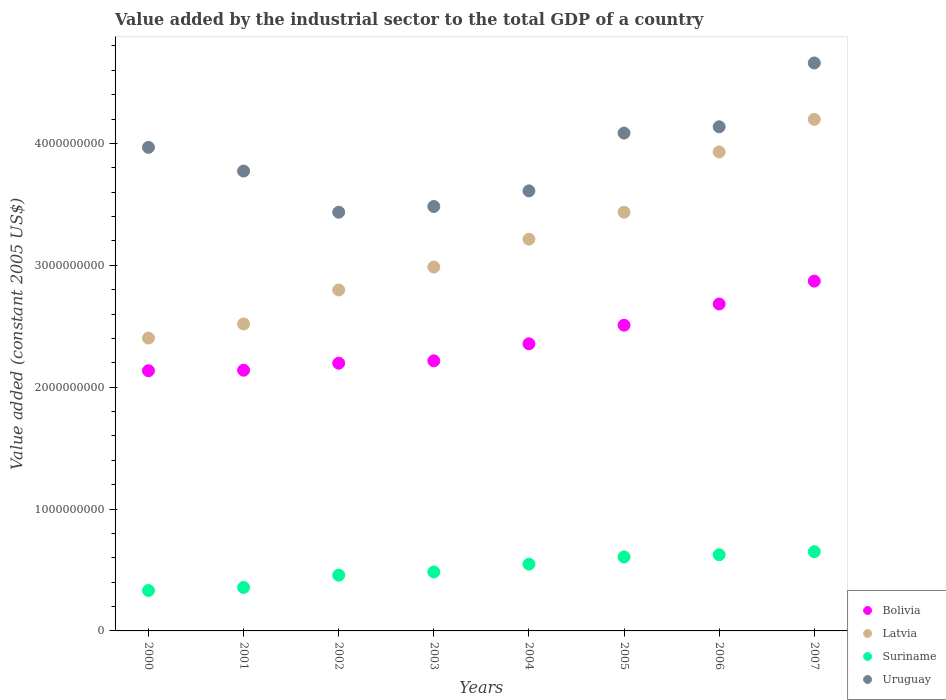How many different coloured dotlines are there?
Make the answer very short. 4. Is the number of dotlines equal to the number of legend labels?
Your answer should be compact. Yes. What is the value added by the industrial sector in Latvia in 2004?
Your answer should be compact. 3.21e+09. Across all years, what is the maximum value added by the industrial sector in Suriname?
Keep it short and to the point. 6.50e+08. Across all years, what is the minimum value added by the industrial sector in Latvia?
Provide a succinct answer. 2.40e+09. In which year was the value added by the industrial sector in Latvia maximum?
Provide a succinct answer. 2007. In which year was the value added by the industrial sector in Suriname minimum?
Make the answer very short. 2000. What is the total value added by the industrial sector in Latvia in the graph?
Ensure brevity in your answer.  2.55e+1. What is the difference between the value added by the industrial sector in Uruguay in 2003 and that in 2004?
Offer a very short reply. -1.28e+08. What is the difference between the value added by the industrial sector in Latvia in 2000 and the value added by the industrial sector in Uruguay in 2005?
Give a very brief answer. -1.68e+09. What is the average value added by the industrial sector in Latvia per year?
Your response must be concise. 3.19e+09. In the year 2006, what is the difference between the value added by the industrial sector in Bolivia and value added by the industrial sector in Suriname?
Keep it short and to the point. 2.06e+09. In how many years, is the value added by the industrial sector in Bolivia greater than 200000000 US$?
Your answer should be compact. 8. What is the ratio of the value added by the industrial sector in Suriname in 2003 to that in 2006?
Make the answer very short. 0.77. Is the value added by the industrial sector in Latvia in 2006 less than that in 2007?
Your answer should be very brief. Yes. What is the difference between the highest and the second highest value added by the industrial sector in Uruguay?
Offer a terse response. 5.24e+08. What is the difference between the highest and the lowest value added by the industrial sector in Latvia?
Your answer should be compact. 1.79e+09. In how many years, is the value added by the industrial sector in Latvia greater than the average value added by the industrial sector in Latvia taken over all years?
Your answer should be very brief. 4. Is it the case that in every year, the sum of the value added by the industrial sector in Latvia and value added by the industrial sector in Uruguay  is greater than the sum of value added by the industrial sector in Bolivia and value added by the industrial sector in Suriname?
Offer a terse response. Yes. Does the value added by the industrial sector in Latvia monotonically increase over the years?
Keep it short and to the point. Yes. How many years are there in the graph?
Make the answer very short. 8. Does the graph contain grids?
Make the answer very short. No. Where does the legend appear in the graph?
Keep it short and to the point. Bottom right. How many legend labels are there?
Offer a very short reply. 4. How are the legend labels stacked?
Provide a short and direct response. Vertical. What is the title of the graph?
Provide a succinct answer. Value added by the industrial sector to the total GDP of a country. What is the label or title of the X-axis?
Keep it short and to the point. Years. What is the label or title of the Y-axis?
Your answer should be compact. Value added (constant 2005 US$). What is the Value added (constant 2005 US$) of Bolivia in 2000?
Your answer should be very brief. 2.13e+09. What is the Value added (constant 2005 US$) in Latvia in 2000?
Offer a very short reply. 2.40e+09. What is the Value added (constant 2005 US$) of Suriname in 2000?
Your answer should be compact. 3.31e+08. What is the Value added (constant 2005 US$) of Uruguay in 2000?
Offer a very short reply. 3.97e+09. What is the Value added (constant 2005 US$) of Bolivia in 2001?
Make the answer very short. 2.14e+09. What is the Value added (constant 2005 US$) in Latvia in 2001?
Your answer should be compact. 2.52e+09. What is the Value added (constant 2005 US$) in Suriname in 2001?
Make the answer very short. 3.57e+08. What is the Value added (constant 2005 US$) in Uruguay in 2001?
Make the answer very short. 3.77e+09. What is the Value added (constant 2005 US$) of Bolivia in 2002?
Make the answer very short. 2.20e+09. What is the Value added (constant 2005 US$) of Latvia in 2002?
Your answer should be very brief. 2.80e+09. What is the Value added (constant 2005 US$) of Suriname in 2002?
Keep it short and to the point. 4.58e+08. What is the Value added (constant 2005 US$) of Uruguay in 2002?
Keep it short and to the point. 3.44e+09. What is the Value added (constant 2005 US$) of Bolivia in 2003?
Provide a succinct answer. 2.22e+09. What is the Value added (constant 2005 US$) of Latvia in 2003?
Keep it short and to the point. 2.99e+09. What is the Value added (constant 2005 US$) of Suriname in 2003?
Ensure brevity in your answer.  4.84e+08. What is the Value added (constant 2005 US$) of Uruguay in 2003?
Your response must be concise. 3.48e+09. What is the Value added (constant 2005 US$) in Bolivia in 2004?
Give a very brief answer. 2.36e+09. What is the Value added (constant 2005 US$) in Latvia in 2004?
Offer a terse response. 3.21e+09. What is the Value added (constant 2005 US$) of Suriname in 2004?
Your response must be concise. 5.48e+08. What is the Value added (constant 2005 US$) in Uruguay in 2004?
Your answer should be compact. 3.61e+09. What is the Value added (constant 2005 US$) of Bolivia in 2005?
Your answer should be very brief. 2.51e+09. What is the Value added (constant 2005 US$) of Latvia in 2005?
Offer a terse response. 3.44e+09. What is the Value added (constant 2005 US$) in Suriname in 2005?
Provide a succinct answer. 6.07e+08. What is the Value added (constant 2005 US$) in Uruguay in 2005?
Ensure brevity in your answer.  4.08e+09. What is the Value added (constant 2005 US$) in Bolivia in 2006?
Keep it short and to the point. 2.68e+09. What is the Value added (constant 2005 US$) of Latvia in 2006?
Provide a succinct answer. 3.93e+09. What is the Value added (constant 2005 US$) of Suriname in 2006?
Offer a terse response. 6.25e+08. What is the Value added (constant 2005 US$) in Uruguay in 2006?
Keep it short and to the point. 4.14e+09. What is the Value added (constant 2005 US$) of Bolivia in 2007?
Provide a short and direct response. 2.87e+09. What is the Value added (constant 2005 US$) of Latvia in 2007?
Provide a short and direct response. 4.20e+09. What is the Value added (constant 2005 US$) in Suriname in 2007?
Your response must be concise. 6.50e+08. What is the Value added (constant 2005 US$) of Uruguay in 2007?
Your response must be concise. 4.66e+09. Across all years, what is the maximum Value added (constant 2005 US$) in Bolivia?
Give a very brief answer. 2.87e+09. Across all years, what is the maximum Value added (constant 2005 US$) in Latvia?
Make the answer very short. 4.20e+09. Across all years, what is the maximum Value added (constant 2005 US$) of Suriname?
Your answer should be compact. 6.50e+08. Across all years, what is the maximum Value added (constant 2005 US$) in Uruguay?
Keep it short and to the point. 4.66e+09. Across all years, what is the minimum Value added (constant 2005 US$) of Bolivia?
Your response must be concise. 2.13e+09. Across all years, what is the minimum Value added (constant 2005 US$) of Latvia?
Ensure brevity in your answer.  2.40e+09. Across all years, what is the minimum Value added (constant 2005 US$) in Suriname?
Give a very brief answer. 3.31e+08. Across all years, what is the minimum Value added (constant 2005 US$) of Uruguay?
Provide a short and direct response. 3.44e+09. What is the total Value added (constant 2005 US$) in Bolivia in the graph?
Provide a succinct answer. 1.91e+1. What is the total Value added (constant 2005 US$) of Latvia in the graph?
Make the answer very short. 2.55e+1. What is the total Value added (constant 2005 US$) in Suriname in the graph?
Make the answer very short. 4.06e+09. What is the total Value added (constant 2005 US$) in Uruguay in the graph?
Give a very brief answer. 3.12e+1. What is the difference between the Value added (constant 2005 US$) of Bolivia in 2000 and that in 2001?
Give a very brief answer. -4.43e+06. What is the difference between the Value added (constant 2005 US$) in Latvia in 2000 and that in 2001?
Give a very brief answer. -1.16e+08. What is the difference between the Value added (constant 2005 US$) of Suriname in 2000 and that in 2001?
Offer a very short reply. -2.52e+07. What is the difference between the Value added (constant 2005 US$) in Uruguay in 2000 and that in 2001?
Your answer should be very brief. 1.94e+08. What is the difference between the Value added (constant 2005 US$) in Bolivia in 2000 and that in 2002?
Keep it short and to the point. -6.17e+07. What is the difference between the Value added (constant 2005 US$) in Latvia in 2000 and that in 2002?
Your answer should be compact. -3.95e+08. What is the difference between the Value added (constant 2005 US$) of Suriname in 2000 and that in 2002?
Give a very brief answer. -1.26e+08. What is the difference between the Value added (constant 2005 US$) in Uruguay in 2000 and that in 2002?
Provide a succinct answer. 5.32e+08. What is the difference between the Value added (constant 2005 US$) of Bolivia in 2000 and that in 2003?
Offer a very short reply. -8.14e+07. What is the difference between the Value added (constant 2005 US$) in Latvia in 2000 and that in 2003?
Make the answer very short. -5.83e+08. What is the difference between the Value added (constant 2005 US$) in Suriname in 2000 and that in 2003?
Ensure brevity in your answer.  -1.52e+08. What is the difference between the Value added (constant 2005 US$) of Uruguay in 2000 and that in 2003?
Offer a very short reply. 4.85e+08. What is the difference between the Value added (constant 2005 US$) in Bolivia in 2000 and that in 2004?
Your response must be concise. -2.21e+08. What is the difference between the Value added (constant 2005 US$) of Latvia in 2000 and that in 2004?
Your response must be concise. -8.11e+08. What is the difference between the Value added (constant 2005 US$) in Suriname in 2000 and that in 2004?
Offer a terse response. -2.16e+08. What is the difference between the Value added (constant 2005 US$) of Uruguay in 2000 and that in 2004?
Offer a terse response. 3.57e+08. What is the difference between the Value added (constant 2005 US$) in Bolivia in 2000 and that in 2005?
Provide a succinct answer. -3.74e+08. What is the difference between the Value added (constant 2005 US$) in Latvia in 2000 and that in 2005?
Your answer should be compact. -1.03e+09. What is the difference between the Value added (constant 2005 US$) in Suriname in 2000 and that in 2005?
Provide a short and direct response. -2.75e+08. What is the difference between the Value added (constant 2005 US$) of Uruguay in 2000 and that in 2005?
Your response must be concise. -1.17e+08. What is the difference between the Value added (constant 2005 US$) in Bolivia in 2000 and that in 2006?
Your response must be concise. -5.48e+08. What is the difference between the Value added (constant 2005 US$) of Latvia in 2000 and that in 2006?
Make the answer very short. -1.53e+09. What is the difference between the Value added (constant 2005 US$) in Suriname in 2000 and that in 2006?
Provide a short and direct response. -2.94e+08. What is the difference between the Value added (constant 2005 US$) of Uruguay in 2000 and that in 2006?
Your answer should be compact. -1.69e+08. What is the difference between the Value added (constant 2005 US$) in Bolivia in 2000 and that in 2007?
Give a very brief answer. -7.35e+08. What is the difference between the Value added (constant 2005 US$) in Latvia in 2000 and that in 2007?
Your answer should be compact. -1.79e+09. What is the difference between the Value added (constant 2005 US$) in Suriname in 2000 and that in 2007?
Make the answer very short. -3.18e+08. What is the difference between the Value added (constant 2005 US$) of Uruguay in 2000 and that in 2007?
Make the answer very short. -6.93e+08. What is the difference between the Value added (constant 2005 US$) of Bolivia in 2001 and that in 2002?
Offer a very short reply. -5.73e+07. What is the difference between the Value added (constant 2005 US$) of Latvia in 2001 and that in 2002?
Provide a short and direct response. -2.79e+08. What is the difference between the Value added (constant 2005 US$) of Suriname in 2001 and that in 2002?
Offer a very short reply. -1.01e+08. What is the difference between the Value added (constant 2005 US$) in Uruguay in 2001 and that in 2002?
Your answer should be very brief. 3.38e+08. What is the difference between the Value added (constant 2005 US$) in Bolivia in 2001 and that in 2003?
Offer a very short reply. -7.70e+07. What is the difference between the Value added (constant 2005 US$) of Latvia in 2001 and that in 2003?
Your response must be concise. -4.67e+08. What is the difference between the Value added (constant 2005 US$) in Suriname in 2001 and that in 2003?
Give a very brief answer. -1.27e+08. What is the difference between the Value added (constant 2005 US$) in Uruguay in 2001 and that in 2003?
Make the answer very short. 2.91e+08. What is the difference between the Value added (constant 2005 US$) of Bolivia in 2001 and that in 2004?
Ensure brevity in your answer.  -2.17e+08. What is the difference between the Value added (constant 2005 US$) of Latvia in 2001 and that in 2004?
Give a very brief answer. -6.95e+08. What is the difference between the Value added (constant 2005 US$) in Suriname in 2001 and that in 2004?
Make the answer very short. -1.91e+08. What is the difference between the Value added (constant 2005 US$) of Uruguay in 2001 and that in 2004?
Offer a terse response. 1.63e+08. What is the difference between the Value added (constant 2005 US$) of Bolivia in 2001 and that in 2005?
Provide a short and direct response. -3.69e+08. What is the difference between the Value added (constant 2005 US$) of Latvia in 2001 and that in 2005?
Give a very brief answer. -9.17e+08. What is the difference between the Value added (constant 2005 US$) of Suriname in 2001 and that in 2005?
Make the answer very short. -2.50e+08. What is the difference between the Value added (constant 2005 US$) of Uruguay in 2001 and that in 2005?
Offer a very short reply. -3.11e+08. What is the difference between the Value added (constant 2005 US$) in Bolivia in 2001 and that in 2006?
Provide a short and direct response. -5.43e+08. What is the difference between the Value added (constant 2005 US$) of Latvia in 2001 and that in 2006?
Provide a succinct answer. -1.41e+09. What is the difference between the Value added (constant 2005 US$) in Suriname in 2001 and that in 2006?
Your response must be concise. -2.68e+08. What is the difference between the Value added (constant 2005 US$) of Uruguay in 2001 and that in 2006?
Offer a very short reply. -3.63e+08. What is the difference between the Value added (constant 2005 US$) in Bolivia in 2001 and that in 2007?
Offer a terse response. -7.31e+08. What is the difference between the Value added (constant 2005 US$) of Latvia in 2001 and that in 2007?
Offer a terse response. -1.68e+09. What is the difference between the Value added (constant 2005 US$) in Suriname in 2001 and that in 2007?
Your response must be concise. -2.93e+08. What is the difference between the Value added (constant 2005 US$) in Uruguay in 2001 and that in 2007?
Your answer should be very brief. -8.87e+08. What is the difference between the Value added (constant 2005 US$) of Bolivia in 2002 and that in 2003?
Offer a very short reply. -1.97e+07. What is the difference between the Value added (constant 2005 US$) in Latvia in 2002 and that in 2003?
Provide a succinct answer. -1.88e+08. What is the difference between the Value added (constant 2005 US$) of Suriname in 2002 and that in 2003?
Your answer should be very brief. -2.63e+07. What is the difference between the Value added (constant 2005 US$) in Uruguay in 2002 and that in 2003?
Make the answer very short. -4.70e+07. What is the difference between the Value added (constant 2005 US$) in Bolivia in 2002 and that in 2004?
Your answer should be very brief. -1.59e+08. What is the difference between the Value added (constant 2005 US$) of Latvia in 2002 and that in 2004?
Provide a short and direct response. -4.17e+08. What is the difference between the Value added (constant 2005 US$) of Suriname in 2002 and that in 2004?
Provide a short and direct response. -9.03e+07. What is the difference between the Value added (constant 2005 US$) in Uruguay in 2002 and that in 2004?
Provide a succinct answer. -1.75e+08. What is the difference between the Value added (constant 2005 US$) in Bolivia in 2002 and that in 2005?
Keep it short and to the point. -3.12e+08. What is the difference between the Value added (constant 2005 US$) in Latvia in 2002 and that in 2005?
Your answer should be very brief. -6.38e+08. What is the difference between the Value added (constant 2005 US$) in Suriname in 2002 and that in 2005?
Your answer should be compact. -1.49e+08. What is the difference between the Value added (constant 2005 US$) in Uruguay in 2002 and that in 2005?
Your answer should be very brief. -6.49e+08. What is the difference between the Value added (constant 2005 US$) of Bolivia in 2002 and that in 2006?
Make the answer very short. -4.86e+08. What is the difference between the Value added (constant 2005 US$) of Latvia in 2002 and that in 2006?
Ensure brevity in your answer.  -1.13e+09. What is the difference between the Value added (constant 2005 US$) in Suriname in 2002 and that in 2006?
Your response must be concise. -1.67e+08. What is the difference between the Value added (constant 2005 US$) in Uruguay in 2002 and that in 2006?
Provide a succinct answer. -7.01e+08. What is the difference between the Value added (constant 2005 US$) in Bolivia in 2002 and that in 2007?
Your answer should be compact. -6.74e+08. What is the difference between the Value added (constant 2005 US$) of Latvia in 2002 and that in 2007?
Your response must be concise. -1.40e+09. What is the difference between the Value added (constant 2005 US$) in Suriname in 2002 and that in 2007?
Your response must be concise. -1.92e+08. What is the difference between the Value added (constant 2005 US$) in Uruguay in 2002 and that in 2007?
Your answer should be compact. -1.22e+09. What is the difference between the Value added (constant 2005 US$) of Bolivia in 2003 and that in 2004?
Offer a very short reply. -1.40e+08. What is the difference between the Value added (constant 2005 US$) of Latvia in 2003 and that in 2004?
Provide a short and direct response. -2.28e+08. What is the difference between the Value added (constant 2005 US$) in Suriname in 2003 and that in 2004?
Your response must be concise. -6.40e+07. What is the difference between the Value added (constant 2005 US$) of Uruguay in 2003 and that in 2004?
Your response must be concise. -1.28e+08. What is the difference between the Value added (constant 2005 US$) of Bolivia in 2003 and that in 2005?
Ensure brevity in your answer.  -2.92e+08. What is the difference between the Value added (constant 2005 US$) in Latvia in 2003 and that in 2005?
Provide a short and direct response. -4.50e+08. What is the difference between the Value added (constant 2005 US$) of Suriname in 2003 and that in 2005?
Offer a very short reply. -1.23e+08. What is the difference between the Value added (constant 2005 US$) in Uruguay in 2003 and that in 2005?
Provide a succinct answer. -6.02e+08. What is the difference between the Value added (constant 2005 US$) of Bolivia in 2003 and that in 2006?
Make the answer very short. -4.66e+08. What is the difference between the Value added (constant 2005 US$) of Latvia in 2003 and that in 2006?
Provide a succinct answer. -9.44e+08. What is the difference between the Value added (constant 2005 US$) of Suriname in 2003 and that in 2006?
Your answer should be very brief. -1.41e+08. What is the difference between the Value added (constant 2005 US$) of Uruguay in 2003 and that in 2006?
Your answer should be very brief. -6.54e+08. What is the difference between the Value added (constant 2005 US$) of Bolivia in 2003 and that in 2007?
Ensure brevity in your answer.  -6.54e+08. What is the difference between the Value added (constant 2005 US$) in Latvia in 2003 and that in 2007?
Make the answer very short. -1.21e+09. What is the difference between the Value added (constant 2005 US$) in Suriname in 2003 and that in 2007?
Provide a short and direct response. -1.66e+08. What is the difference between the Value added (constant 2005 US$) of Uruguay in 2003 and that in 2007?
Provide a short and direct response. -1.18e+09. What is the difference between the Value added (constant 2005 US$) of Bolivia in 2004 and that in 2005?
Ensure brevity in your answer.  -1.53e+08. What is the difference between the Value added (constant 2005 US$) in Latvia in 2004 and that in 2005?
Make the answer very short. -2.21e+08. What is the difference between the Value added (constant 2005 US$) in Suriname in 2004 and that in 2005?
Provide a short and direct response. -5.92e+07. What is the difference between the Value added (constant 2005 US$) in Uruguay in 2004 and that in 2005?
Make the answer very short. -4.74e+08. What is the difference between the Value added (constant 2005 US$) of Bolivia in 2004 and that in 2006?
Offer a very short reply. -3.26e+08. What is the difference between the Value added (constant 2005 US$) in Latvia in 2004 and that in 2006?
Give a very brief answer. -7.16e+08. What is the difference between the Value added (constant 2005 US$) of Suriname in 2004 and that in 2006?
Provide a short and direct response. -7.72e+07. What is the difference between the Value added (constant 2005 US$) in Uruguay in 2004 and that in 2006?
Give a very brief answer. -5.26e+08. What is the difference between the Value added (constant 2005 US$) of Bolivia in 2004 and that in 2007?
Provide a short and direct response. -5.14e+08. What is the difference between the Value added (constant 2005 US$) of Latvia in 2004 and that in 2007?
Keep it short and to the point. -9.83e+08. What is the difference between the Value added (constant 2005 US$) of Suriname in 2004 and that in 2007?
Provide a succinct answer. -1.02e+08. What is the difference between the Value added (constant 2005 US$) in Uruguay in 2004 and that in 2007?
Your answer should be very brief. -1.05e+09. What is the difference between the Value added (constant 2005 US$) of Bolivia in 2005 and that in 2006?
Offer a terse response. -1.74e+08. What is the difference between the Value added (constant 2005 US$) of Latvia in 2005 and that in 2006?
Your response must be concise. -4.95e+08. What is the difference between the Value added (constant 2005 US$) of Suriname in 2005 and that in 2006?
Make the answer very short. -1.81e+07. What is the difference between the Value added (constant 2005 US$) in Uruguay in 2005 and that in 2006?
Your answer should be very brief. -5.16e+07. What is the difference between the Value added (constant 2005 US$) in Bolivia in 2005 and that in 2007?
Give a very brief answer. -3.62e+08. What is the difference between the Value added (constant 2005 US$) in Latvia in 2005 and that in 2007?
Ensure brevity in your answer.  -7.62e+08. What is the difference between the Value added (constant 2005 US$) of Suriname in 2005 and that in 2007?
Your answer should be compact. -4.30e+07. What is the difference between the Value added (constant 2005 US$) of Uruguay in 2005 and that in 2007?
Provide a short and direct response. -5.75e+08. What is the difference between the Value added (constant 2005 US$) in Bolivia in 2006 and that in 2007?
Provide a short and direct response. -1.88e+08. What is the difference between the Value added (constant 2005 US$) of Latvia in 2006 and that in 2007?
Your answer should be compact. -2.67e+08. What is the difference between the Value added (constant 2005 US$) in Suriname in 2006 and that in 2007?
Offer a very short reply. -2.49e+07. What is the difference between the Value added (constant 2005 US$) in Uruguay in 2006 and that in 2007?
Your answer should be very brief. -5.24e+08. What is the difference between the Value added (constant 2005 US$) of Bolivia in 2000 and the Value added (constant 2005 US$) of Latvia in 2001?
Keep it short and to the point. -3.84e+08. What is the difference between the Value added (constant 2005 US$) in Bolivia in 2000 and the Value added (constant 2005 US$) in Suriname in 2001?
Ensure brevity in your answer.  1.78e+09. What is the difference between the Value added (constant 2005 US$) of Bolivia in 2000 and the Value added (constant 2005 US$) of Uruguay in 2001?
Your answer should be compact. -1.64e+09. What is the difference between the Value added (constant 2005 US$) in Latvia in 2000 and the Value added (constant 2005 US$) in Suriname in 2001?
Keep it short and to the point. 2.05e+09. What is the difference between the Value added (constant 2005 US$) in Latvia in 2000 and the Value added (constant 2005 US$) in Uruguay in 2001?
Provide a succinct answer. -1.37e+09. What is the difference between the Value added (constant 2005 US$) in Suriname in 2000 and the Value added (constant 2005 US$) in Uruguay in 2001?
Give a very brief answer. -3.44e+09. What is the difference between the Value added (constant 2005 US$) of Bolivia in 2000 and the Value added (constant 2005 US$) of Latvia in 2002?
Your answer should be compact. -6.63e+08. What is the difference between the Value added (constant 2005 US$) of Bolivia in 2000 and the Value added (constant 2005 US$) of Suriname in 2002?
Keep it short and to the point. 1.68e+09. What is the difference between the Value added (constant 2005 US$) of Bolivia in 2000 and the Value added (constant 2005 US$) of Uruguay in 2002?
Ensure brevity in your answer.  -1.30e+09. What is the difference between the Value added (constant 2005 US$) in Latvia in 2000 and the Value added (constant 2005 US$) in Suriname in 2002?
Give a very brief answer. 1.95e+09. What is the difference between the Value added (constant 2005 US$) in Latvia in 2000 and the Value added (constant 2005 US$) in Uruguay in 2002?
Offer a very short reply. -1.03e+09. What is the difference between the Value added (constant 2005 US$) of Suriname in 2000 and the Value added (constant 2005 US$) of Uruguay in 2002?
Ensure brevity in your answer.  -3.10e+09. What is the difference between the Value added (constant 2005 US$) in Bolivia in 2000 and the Value added (constant 2005 US$) in Latvia in 2003?
Provide a short and direct response. -8.51e+08. What is the difference between the Value added (constant 2005 US$) of Bolivia in 2000 and the Value added (constant 2005 US$) of Suriname in 2003?
Make the answer very short. 1.65e+09. What is the difference between the Value added (constant 2005 US$) in Bolivia in 2000 and the Value added (constant 2005 US$) in Uruguay in 2003?
Offer a terse response. -1.35e+09. What is the difference between the Value added (constant 2005 US$) in Latvia in 2000 and the Value added (constant 2005 US$) in Suriname in 2003?
Offer a very short reply. 1.92e+09. What is the difference between the Value added (constant 2005 US$) in Latvia in 2000 and the Value added (constant 2005 US$) in Uruguay in 2003?
Make the answer very short. -1.08e+09. What is the difference between the Value added (constant 2005 US$) of Suriname in 2000 and the Value added (constant 2005 US$) of Uruguay in 2003?
Offer a very short reply. -3.15e+09. What is the difference between the Value added (constant 2005 US$) in Bolivia in 2000 and the Value added (constant 2005 US$) in Latvia in 2004?
Provide a short and direct response. -1.08e+09. What is the difference between the Value added (constant 2005 US$) in Bolivia in 2000 and the Value added (constant 2005 US$) in Suriname in 2004?
Ensure brevity in your answer.  1.59e+09. What is the difference between the Value added (constant 2005 US$) in Bolivia in 2000 and the Value added (constant 2005 US$) in Uruguay in 2004?
Provide a succinct answer. -1.48e+09. What is the difference between the Value added (constant 2005 US$) in Latvia in 2000 and the Value added (constant 2005 US$) in Suriname in 2004?
Your answer should be compact. 1.85e+09. What is the difference between the Value added (constant 2005 US$) of Latvia in 2000 and the Value added (constant 2005 US$) of Uruguay in 2004?
Your answer should be compact. -1.21e+09. What is the difference between the Value added (constant 2005 US$) of Suriname in 2000 and the Value added (constant 2005 US$) of Uruguay in 2004?
Make the answer very short. -3.28e+09. What is the difference between the Value added (constant 2005 US$) in Bolivia in 2000 and the Value added (constant 2005 US$) in Latvia in 2005?
Offer a terse response. -1.30e+09. What is the difference between the Value added (constant 2005 US$) in Bolivia in 2000 and the Value added (constant 2005 US$) in Suriname in 2005?
Your response must be concise. 1.53e+09. What is the difference between the Value added (constant 2005 US$) of Bolivia in 2000 and the Value added (constant 2005 US$) of Uruguay in 2005?
Make the answer very short. -1.95e+09. What is the difference between the Value added (constant 2005 US$) of Latvia in 2000 and the Value added (constant 2005 US$) of Suriname in 2005?
Provide a succinct answer. 1.80e+09. What is the difference between the Value added (constant 2005 US$) in Latvia in 2000 and the Value added (constant 2005 US$) in Uruguay in 2005?
Offer a very short reply. -1.68e+09. What is the difference between the Value added (constant 2005 US$) in Suriname in 2000 and the Value added (constant 2005 US$) in Uruguay in 2005?
Your response must be concise. -3.75e+09. What is the difference between the Value added (constant 2005 US$) in Bolivia in 2000 and the Value added (constant 2005 US$) in Latvia in 2006?
Keep it short and to the point. -1.80e+09. What is the difference between the Value added (constant 2005 US$) of Bolivia in 2000 and the Value added (constant 2005 US$) of Suriname in 2006?
Ensure brevity in your answer.  1.51e+09. What is the difference between the Value added (constant 2005 US$) of Bolivia in 2000 and the Value added (constant 2005 US$) of Uruguay in 2006?
Provide a succinct answer. -2.00e+09. What is the difference between the Value added (constant 2005 US$) of Latvia in 2000 and the Value added (constant 2005 US$) of Suriname in 2006?
Offer a very short reply. 1.78e+09. What is the difference between the Value added (constant 2005 US$) of Latvia in 2000 and the Value added (constant 2005 US$) of Uruguay in 2006?
Offer a terse response. -1.73e+09. What is the difference between the Value added (constant 2005 US$) in Suriname in 2000 and the Value added (constant 2005 US$) in Uruguay in 2006?
Keep it short and to the point. -3.81e+09. What is the difference between the Value added (constant 2005 US$) in Bolivia in 2000 and the Value added (constant 2005 US$) in Latvia in 2007?
Offer a very short reply. -2.06e+09. What is the difference between the Value added (constant 2005 US$) of Bolivia in 2000 and the Value added (constant 2005 US$) of Suriname in 2007?
Keep it short and to the point. 1.48e+09. What is the difference between the Value added (constant 2005 US$) of Bolivia in 2000 and the Value added (constant 2005 US$) of Uruguay in 2007?
Provide a short and direct response. -2.53e+09. What is the difference between the Value added (constant 2005 US$) in Latvia in 2000 and the Value added (constant 2005 US$) in Suriname in 2007?
Offer a terse response. 1.75e+09. What is the difference between the Value added (constant 2005 US$) in Latvia in 2000 and the Value added (constant 2005 US$) in Uruguay in 2007?
Keep it short and to the point. -2.26e+09. What is the difference between the Value added (constant 2005 US$) in Suriname in 2000 and the Value added (constant 2005 US$) in Uruguay in 2007?
Give a very brief answer. -4.33e+09. What is the difference between the Value added (constant 2005 US$) of Bolivia in 2001 and the Value added (constant 2005 US$) of Latvia in 2002?
Give a very brief answer. -6.58e+08. What is the difference between the Value added (constant 2005 US$) of Bolivia in 2001 and the Value added (constant 2005 US$) of Suriname in 2002?
Provide a succinct answer. 1.68e+09. What is the difference between the Value added (constant 2005 US$) in Bolivia in 2001 and the Value added (constant 2005 US$) in Uruguay in 2002?
Ensure brevity in your answer.  -1.30e+09. What is the difference between the Value added (constant 2005 US$) of Latvia in 2001 and the Value added (constant 2005 US$) of Suriname in 2002?
Your answer should be very brief. 2.06e+09. What is the difference between the Value added (constant 2005 US$) in Latvia in 2001 and the Value added (constant 2005 US$) in Uruguay in 2002?
Your response must be concise. -9.17e+08. What is the difference between the Value added (constant 2005 US$) of Suriname in 2001 and the Value added (constant 2005 US$) of Uruguay in 2002?
Ensure brevity in your answer.  -3.08e+09. What is the difference between the Value added (constant 2005 US$) in Bolivia in 2001 and the Value added (constant 2005 US$) in Latvia in 2003?
Make the answer very short. -8.46e+08. What is the difference between the Value added (constant 2005 US$) of Bolivia in 2001 and the Value added (constant 2005 US$) of Suriname in 2003?
Ensure brevity in your answer.  1.66e+09. What is the difference between the Value added (constant 2005 US$) of Bolivia in 2001 and the Value added (constant 2005 US$) of Uruguay in 2003?
Give a very brief answer. -1.34e+09. What is the difference between the Value added (constant 2005 US$) of Latvia in 2001 and the Value added (constant 2005 US$) of Suriname in 2003?
Your answer should be very brief. 2.04e+09. What is the difference between the Value added (constant 2005 US$) in Latvia in 2001 and the Value added (constant 2005 US$) in Uruguay in 2003?
Keep it short and to the point. -9.64e+08. What is the difference between the Value added (constant 2005 US$) in Suriname in 2001 and the Value added (constant 2005 US$) in Uruguay in 2003?
Provide a short and direct response. -3.13e+09. What is the difference between the Value added (constant 2005 US$) in Bolivia in 2001 and the Value added (constant 2005 US$) in Latvia in 2004?
Your response must be concise. -1.07e+09. What is the difference between the Value added (constant 2005 US$) of Bolivia in 2001 and the Value added (constant 2005 US$) of Suriname in 2004?
Offer a very short reply. 1.59e+09. What is the difference between the Value added (constant 2005 US$) of Bolivia in 2001 and the Value added (constant 2005 US$) of Uruguay in 2004?
Make the answer very short. -1.47e+09. What is the difference between the Value added (constant 2005 US$) of Latvia in 2001 and the Value added (constant 2005 US$) of Suriname in 2004?
Make the answer very short. 1.97e+09. What is the difference between the Value added (constant 2005 US$) in Latvia in 2001 and the Value added (constant 2005 US$) in Uruguay in 2004?
Offer a terse response. -1.09e+09. What is the difference between the Value added (constant 2005 US$) in Suriname in 2001 and the Value added (constant 2005 US$) in Uruguay in 2004?
Your response must be concise. -3.25e+09. What is the difference between the Value added (constant 2005 US$) of Bolivia in 2001 and the Value added (constant 2005 US$) of Latvia in 2005?
Your answer should be very brief. -1.30e+09. What is the difference between the Value added (constant 2005 US$) in Bolivia in 2001 and the Value added (constant 2005 US$) in Suriname in 2005?
Ensure brevity in your answer.  1.53e+09. What is the difference between the Value added (constant 2005 US$) in Bolivia in 2001 and the Value added (constant 2005 US$) in Uruguay in 2005?
Provide a succinct answer. -1.95e+09. What is the difference between the Value added (constant 2005 US$) of Latvia in 2001 and the Value added (constant 2005 US$) of Suriname in 2005?
Your answer should be very brief. 1.91e+09. What is the difference between the Value added (constant 2005 US$) of Latvia in 2001 and the Value added (constant 2005 US$) of Uruguay in 2005?
Keep it short and to the point. -1.57e+09. What is the difference between the Value added (constant 2005 US$) of Suriname in 2001 and the Value added (constant 2005 US$) of Uruguay in 2005?
Offer a very short reply. -3.73e+09. What is the difference between the Value added (constant 2005 US$) in Bolivia in 2001 and the Value added (constant 2005 US$) in Latvia in 2006?
Make the answer very short. -1.79e+09. What is the difference between the Value added (constant 2005 US$) of Bolivia in 2001 and the Value added (constant 2005 US$) of Suriname in 2006?
Keep it short and to the point. 1.51e+09. What is the difference between the Value added (constant 2005 US$) in Bolivia in 2001 and the Value added (constant 2005 US$) in Uruguay in 2006?
Offer a very short reply. -2.00e+09. What is the difference between the Value added (constant 2005 US$) of Latvia in 2001 and the Value added (constant 2005 US$) of Suriname in 2006?
Your answer should be very brief. 1.89e+09. What is the difference between the Value added (constant 2005 US$) of Latvia in 2001 and the Value added (constant 2005 US$) of Uruguay in 2006?
Offer a very short reply. -1.62e+09. What is the difference between the Value added (constant 2005 US$) in Suriname in 2001 and the Value added (constant 2005 US$) in Uruguay in 2006?
Provide a succinct answer. -3.78e+09. What is the difference between the Value added (constant 2005 US$) of Bolivia in 2001 and the Value added (constant 2005 US$) of Latvia in 2007?
Your answer should be compact. -2.06e+09. What is the difference between the Value added (constant 2005 US$) in Bolivia in 2001 and the Value added (constant 2005 US$) in Suriname in 2007?
Give a very brief answer. 1.49e+09. What is the difference between the Value added (constant 2005 US$) of Bolivia in 2001 and the Value added (constant 2005 US$) of Uruguay in 2007?
Provide a succinct answer. -2.52e+09. What is the difference between the Value added (constant 2005 US$) of Latvia in 2001 and the Value added (constant 2005 US$) of Suriname in 2007?
Provide a succinct answer. 1.87e+09. What is the difference between the Value added (constant 2005 US$) in Latvia in 2001 and the Value added (constant 2005 US$) in Uruguay in 2007?
Make the answer very short. -2.14e+09. What is the difference between the Value added (constant 2005 US$) in Suriname in 2001 and the Value added (constant 2005 US$) in Uruguay in 2007?
Offer a terse response. -4.30e+09. What is the difference between the Value added (constant 2005 US$) of Bolivia in 2002 and the Value added (constant 2005 US$) of Latvia in 2003?
Keep it short and to the point. -7.89e+08. What is the difference between the Value added (constant 2005 US$) in Bolivia in 2002 and the Value added (constant 2005 US$) in Suriname in 2003?
Provide a short and direct response. 1.71e+09. What is the difference between the Value added (constant 2005 US$) of Bolivia in 2002 and the Value added (constant 2005 US$) of Uruguay in 2003?
Keep it short and to the point. -1.29e+09. What is the difference between the Value added (constant 2005 US$) of Latvia in 2002 and the Value added (constant 2005 US$) of Suriname in 2003?
Keep it short and to the point. 2.31e+09. What is the difference between the Value added (constant 2005 US$) in Latvia in 2002 and the Value added (constant 2005 US$) in Uruguay in 2003?
Ensure brevity in your answer.  -6.85e+08. What is the difference between the Value added (constant 2005 US$) in Suriname in 2002 and the Value added (constant 2005 US$) in Uruguay in 2003?
Keep it short and to the point. -3.02e+09. What is the difference between the Value added (constant 2005 US$) in Bolivia in 2002 and the Value added (constant 2005 US$) in Latvia in 2004?
Your answer should be compact. -1.02e+09. What is the difference between the Value added (constant 2005 US$) in Bolivia in 2002 and the Value added (constant 2005 US$) in Suriname in 2004?
Your answer should be compact. 1.65e+09. What is the difference between the Value added (constant 2005 US$) in Bolivia in 2002 and the Value added (constant 2005 US$) in Uruguay in 2004?
Offer a terse response. -1.41e+09. What is the difference between the Value added (constant 2005 US$) in Latvia in 2002 and the Value added (constant 2005 US$) in Suriname in 2004?
Offer a very short reply. 2.25e+09. What is the difference between the Value added (constant 2005 US$) in Latvia in 2002 and the Value added (constant 2005 US$) in Uruguay in 2004?
Offer a very short reply. -8.13e+08. What is the difference between the Value added (constant 2005 US$) of Suriname in 2002 and the Value added (constant 2005 US$) of Uruguay in 2004?
Give a very brief answer. -3.15e+09. What is the difference between the Value added (constant 2005 US$) of Bolivia in 2002 and the Value added (constant 2005 US$) of Latvia in 2005?
Your answer should be compact. -1.24e+09. What is the difference between the Value added (constant 2005 US$) in Bolivia in 2002 and the Value added (constant 2005 US$) in Suriname in 2005?
Make the answer very short. 1.59e+09. What is the difference between the Value added (constant 2005 US$) in Bolivia in 2002 and the Value added (constant 2005 US$) in Uruguay in 2005?
Your answer should be compact. -1.89e+09. What is the difference between the Value added (constant 2005 US$) in Latvia in 2002 and the Value added (constant 2005 US$) in Suriname in 2005?
Your response must be concise. 2.19e+09. What is the difference between the Value added (constant 2005 US$) of Latvia in 2002 and the Value added (constant 2005 US$) of Uruguay in 2005?
Ensure brevity in your answer.  -1.29e+09. What is the difference between the Value added (constant 2005 US$) in Suriname in 2002 and the Value added (constant 2005 US$) in Uruguay in 2005?
Make the answer very short. -3.63e+09. What is the difference between the Value added (constant 2005 US$) of Bolivia in 2002 and the Value added (constant 2005 US$) of Latvia in 2006?
Your answer should be compact. -1.73e+09. What is the difference between the Value added (constant 2005 US$) of Bolivia in 2002 and the Value added (constant 2005 US$) of Suriname in 2006?
Make the answer very short. 1.57e+09. What is the difference between the Value added (constant 2005 US$) in Bolivia in 2002 and the Value added (constant 2005 US$) in Uruguay in 2006?
Provide a succinct answer. -1.94e+09. What is the difference between the Value added (constant 2005 US$) in Latvia in 2002 and the Value added (constant 2005 US$) in Suriname in 2006?
Your answer should be compact. 2.17e+09. What is the difference between the Value added (constant 2005 US$) of Latvia in 2002 and the Value added (constant 2005 US$) of Uruguay in 2006?
Make the answer very short. -1.34e+09. What is the difference between the Value added (constant 2005 US$) of Suriname in 2002 and the Value added (constant 2005 US$) of Uruguay in 2006?
Provide a succinct answer. -3.68e+09. What is the difference between the Value added (constant 2005 US$) in Bolivia in 2002 and the Value added (constant 2005 US$) in Latvia in 2007?
Give a very brief answer. -2.00e+09. What is the difference between the Value added (constant 2005 US$) of Bolivia in 2002 and the Value added (constant 2005 US$) of Suriname in 2007?
Your answer should be compact. 1.55e+09. What is the difference between the Value added (constant 2005 US$) of Bolivia in 2002 and the Value added (constant 2005 US$) of Uruguay in 2007?
Provide a short and direct response. -2.46e+09. What is the difference between the Value added (constant 2005 US$) of Latvia in 2002 and the Value added (constant 2005 US$) of Suriname in 2007?
Offer a very short reply. 2.15e+09. What is the difference between the Value added (constant 2005 US$) in Latvia in 2002 and the Value added (constant 2005 US$) in Uruguay in 2007?
Give a very brief answer. -1.86e+09. What is the difference between the Value added (constant 2005 US$) of Suriname in 2002 and the Value added (constant 2005 US$) of Uruguay in 2007?
Give a very brief answer. -4.20e+09. What is the difference between the Value added (constant 2005 US$) of Bolivia in 2003 and the Value added (constant 2005 US$) of Latvia in 2004?
Offer a terse response. -9.98e+08. What is the difference between the Value added (constant 2005 US$) in Bolivia in 2003 and the Value added (constant 2005 US$) in Suriname in 2004?
Your answer should be compact. 1.67e+09. What is the difference between the Value added (constant 2005 US$) in Bolivia in 2003 and the Value added (constant 2005 US$) in Uruguay in 2004?
Keep it short and to the point. -1.39e+09. What is the difference between the Value added (constant 2005 US$) of Latvia in 2003 and the Value added (constant 2005 US$) of Suriname in 2004?
Keep it short and to the point. 2.44e+09. What is the difference between the Value added (constant 2005 US$) in Latvia in 2003 and the Value added (constant 2005 US$) in Uruguay in 2004?
Offer a terse response. -6.25e+08. What is the difference between the Value added (constant 2005 US$) in Suriname in 2003 and the Value added (constant 2005 US$) in Uruguay in 2004?
Offer a very short reply. -3.13e+09. What is the difference between the Value added (constant 2005 US$) of Bolivia in 2003 and the Value added (constant 2005 US$) of Latvia in 2005?
Make the answer very short. -1.22e+09. What is the difference between the Value added (constant 2005 US$) of Bolivia in 2003 and the Value added (constant 2005 US$) of Suriname in 2005?
Provide a succinct answer. 1.61e+09. What is the difference between the Value added (constant 2005 US$) in Bolivia in 2003 and the Value added (constant 2005 US$) in Uruguay in 2005?
Offer a terse response. -1.87e+09. What is the difference between the Value added (constant 2005 US$) in Latvia in 2003 and the Value added (constant 2005 US$) in Suriname in 2005?
Your answer should be very brief. 2.38e+09. What is the difference between the Value added (constant 2005 US$) of Latvia in 2003 and the Value added (constant 2005 US$) of Uruguay in 2005?
Your answer should be very brief. -1.10e+09. What is the difference between the Value added (constant 2005 US$) of Suriname in 2003 and the Value added (constant 2005 US$) of Uruguay in 2005?
Make the answer very short. -3.60e+09. What is the difference between the Value added (constant 2005 US$) in Bolivia in 2003 and the Value added (constant 2005 US$) in Latvia in 2006?
Keep it short and to the point. -1.71e+09. What is the difference between the Value added (constant 2005 US$) of Bolivia in 2003 and the Value added (constant 2005 US$) of Suriname in 2006?
Your answer should be very brief. 1.59e+09. What is the difference between the Value added (constant 2005 US$) of Bolivia in 2003 and the Value added (constant 2005 US$) of Uruguay in 2006?
Make the answer very short. -1.92e+09. What is the difference between the Value added (constant 2005 US$) in Latvia in 2003 and the Value added (constant 2005 US$) in Suriname in 2006?
Make the answer very short. 2.36e+09. What is the difference between the Value added (constant 2005 US$) of Latvia in 2003 and the Value added (constant 2005 US$) of Uruguay in 2006?
Keep it short and to the point. -1.15e+09. What is the difference between the Value added (constant 2005 US$) in Suriname in 2003 and the Value added (constant 2005 US$) in Uruguay in 2006?
Keep it short and to the point. -3.65e+09. What is the difference between the Value added (constant 2005 US$) of Bolivia in 2003 and the Value added (constant 2005 US$) of Latvia in 2007?
Provide a succinct answer. -1.98e+09. What is the difference between the Value added (constant 2005 US$) of Bolivia in 2003 and the Value added (constant 2005 US$) of Suriname in 2007?
Your answer should be very brief. 1.57e+09. What is the difference between the Value added (constant 2005 US$) of Bolivia in 2003 and the Value added (constant 2005 US$) of Uruguay in 2007?
Keep it short and to the point. -2.44e+09. What is the difference between the Value added (constant 2005 US$) of Latvia in 2003 and the Value added (constant 2005 US$) of Suriname in 2007?
Make the answer very short. 2.34e+09. What is the difference between the Value added (constant 2005 US$) of Latvia in 2003 and the Value added (constant 2005 US$) of Uruguay in 2007?
Provide a succinct answer. -1.67e+09. What is the difference between the Value added (constant 2005 US$) in Suriname in 2003 and the Value added (constant 2005 US$) in Uruguay in 2007?
Ensure brevity in your answer.  -4.18e+09. What is the difference between the Value added (constant 2005 US$) in Bolivia in 2004 and the Value added (constant 2005 US$) in Latvia in 2005?
Offer a very short reply. -1.08e+09. What is the difference between the Value added (constant 2005 US$) in Bolivia in 2004 and the Value added (constant 2005 US$) in Suriname in 2005?
Keep it short and to the point. 1.75e+09. What is the difference between the Value added (constant 2005 US$) in Bolivia in 2004 and the Value added (constant 2005 US$) in Uruguay in 2005?
Give a very brief answer. -1.73e+09. What is the difference between the Value added (constant 2005 US$) in Latvia in 2004 and the Value added (constant 2005 US$) in Suriname in 2005?
Provide a short and direct response. 2.61e+09. What is the difference between the Value added (constant 2005 US$) of Latvia in 2004 and the Value added (constant 2005 US$) of Uruguay in 2005?
Offer a very short reply. -8.71e+08. What is the difference between the Value added (constant 2005 US$) in Suriname in 2004 and the Value added (constant 2005 US$) in Uruguay in 2005?
Offer a very short reply. -3.54e+09. What is the difference between the Value added (constant 2005 US$) in Bolivia in 2004 and the Value added (constant 2005 US$) in Latvia in 2006?
Your answer should be compact. -1.57e+09. What is the difference between the Value added (constant 2005 US$) of Bolivia in 2004 and the Value added (constant 2005 US$) of Suriname in 2006?
Your response must be concise. 1.73e+09. What is the difference between the Value added (constant 2005 US$) in Bolivia in 2004 and the Value added (constant 2005 US$) in Uruguay in 2006?
Your response must be concise. -1.78e+09. What is the difference between the Value added (constant 2005 US$) of Latvia in 2004 and the Value added (constant 2005 US$) of Suriname in 2006?
Provide a succinct answer. 2.59e+09. What is the difference between the Value added (constant 2005 US$) in Latvia in 2004 and the Value added (constant 2005 US$) in Uruguay in 2006?
Ensure brevity in your answer.  -9.22e+08. What is the difference between the Value added (constant 2005 US$) in Suriname in 2004 and the Value added (constant 2005 US$) in Uruguay in 2006?
Provide a short and direct response. -3.59e+09. What is the difference between the Value added (constant 2005 US$) of Bolivia in 2004 and the Value added (constant 2005 US$) of Latvia in 2007?
Keep it short and to the point. -1.84e+09. What is the difference between the Value added (constant 2005 US$) in Bolivia in 2004 and the Value added (constant 2005 US$) in Suriname in 2007?
Your answer should be very brief. 1.71e+09. What is the difference between the Value added (constant 2005 US$) of Bolivia in 2004 and the Value added (constant 2005 US$) of Uruguay in 2007?
Provide a short and direct response. -2.30e+09. What is the difference between the Value added (constant 2005 US$) in Latvia in 2004 and the Value added (constant 2005 US$) in Suriname in 2007?
Give a very brief answer. 2.56e+09. What is the difference between the Value added (constant 2005 US$) in Latvia in 2004 and the Value added (constant 2005 US$) in Uruguay in 2007?
Your answer should be compact. -1.45e+09. What is the difference between the Value added (constant 2005 US$) in Suriname in 2004 and the Value added (constant 2005 US$) in Uruguay in 2007?
Your answer should be compact. -4.11e+09. What is the difference between the Value added (constant 2005 US$) in Bolivia in 2005 and the Value added (constant 2005 US$) in Latvia in 2006?
Provide a succinct answer. -1.42e+09. What is the difference between the Value added (constant 2005 US$) of Bolivia in 2005 and the Value added (constant 2005 US$) of Suriname in 2006?
Ensure brevity in your answer.  1.88e+09. What is the difference between the Value added (constant 2005 US$) in Bolivia in 2005 and the Value added (constant 2005 US$) in Uruguay in 2006?
Keep it short and to the point. -1.63e+09. What is the difference between the Value added (constant 2005 US$) in Latvia in 2005 and the Value added (constant 2005 US$) in Suriname in 2006?
Ensure brevity in your answer.  2.81e+09. What is the difference between the Value added (constant 2005 US$) of Latvia in 2005 and the Value added (constant 2005 US$) of Uruguay in 2006?
Keep it short and to the point. -7.01e+08. What is the difference between the Value added (constant 2005 US$) in Suriname in 2005 and the Value added (constant 2005 US$) in Uruguay in 2006?
Your response must be concise. -3.53e+09. What is the difference between the Value added (constant 2005 US$) of Bolivia in 2005 and the Value added (constant 2005 US$) of Latvia in 2007?
Your response must be concise. -1.69e+09. What is the difference between the Value added (constant 2005 US$) of Bolivia in 2005 and the Value added (constant 2005 US$) of Suriname in 2007?
Offer a very short reply. 1.86e+09. What is the difference between the Value added (constant 2005 US$) of Bolivia in 2005 and the Value added (constant 2005 US$) of Uruguay in 2007?
Ensure brevity in your answer.  -2.15e+09. What is the difference between the Value added (constant 2005 US$) of Latvia in 2005 and the Value added (constant 2005 US$) of Suriname in 2007?
Your answer should be very brief. 2.79e+09. What is the difference between the Value added (constant 2005 US$) of Latvia in 2005 and the Value added (constant 2005 US$) of Uruguay in 2007?
Offer a very short reply. -1.22e+09. What is the difference between the Value added (constant 2005 US$) of Suriname in 2005 and the Value added (constant 2005 US$) of Uruguay in 2007?
Your answer should be very brief. -4.05e+09. What is the difference between the Value added (constant 2005 US$) in Bolivia in 2006 and the Value added (constant 2005 US$) in Latvia in 2007?
Give a very brief answer. -1.51e+09. What is the difference between the Value added (constant 2005 US$) of Bolivia in 2006 and the Value added (constant 2005 US$) of Suriname in 2007?
Make the answer very short. 2.03e+09. What is the difference between the Value added (constant 2005 US$) of Bolivia in 2006 and the Value added (constant 2005 US$) of Uruguay in 2007?
Your response must be concise. -1.98e+09. What is the difference between the Value added (constant 2005 US$) in Latvia in 2006 and the Value added (constant 2005 US$) in Suriname in 2007?
Your answer should be very brief. 3.28e+09. What is the difference between the Value added (constant 2005 US$) in Latvia in 2006 and the Value added (constant 2005 US$) in Uruguay in 2007?
Give a very brief answer. -7.30e+08. What is the difference between the Value added (constant 2005 US$) in Suriname in 2006 and the Value added (constant 2005 US$) in Uruguay in 2007?
Make the answer very short. -4.04e+09. What is the average Value added (constant 2005 US$) of Bolivia per year?
Your answer should be very brief. 2.39e+09. What is the average Value added (constant 2005 US$) in Latvia per year?
Ensure brevity in your answer.  3.19e+09. What is the average Value added (constant 2005 US$) of Suriname per year?
Offer a terse response. 5.07e+08. What is the average Value added (constant 2005 US$) of Uruguay per year?
Your answer should be very brief. 3.89e+09. In the year 2000, what is the difference between the Value added (constant 2005 US$) in Bolivia and Value added (constant 2005 US$) in Latvia?
Keep it short and to the point. -2.68e+08. In the year 2000, what is the difference between the Value added (constant 2005 US$) of Bolivia and Value added (constant 2005 US$) of Suriname?
Your response must be concise. 1.80e+09. In the year 2000, what is the difference between the Value added (constant 2005 US$) of Bolivia and Value added (constant 2005 US$) of Uruguay?
Offer a terse response. -1.83e+09. In the year 2000, what is the difference between the Value added (constant 2005 US$) of Latvia and Value added (constant 2005 US$) of Suriname?
Keep it short and to the point. 2.07e+09. In the year 2000, what is the difference between the Value added (constant 2005 US$) of Latvia and Value added (constant 2005 US$) of Uruguay?
Your response must be concise. -1.56e+09. In the year 2000, what is the difference between the Value added (constant 2005 US$) of Suriname and Value added (constant 2005 US$) of Uruguay?
Your response must be concise. -3.64e+09. In the year 2001, what is the difference between the Value added (constant 2005 US$) of Bolivia and Value added (constant 2005 US$) of Latvia?
Your response must be concise. -3.80e+08. In the year 2001, what is the difference between the Value added (constant 2005 US$) in Bolivia and Value added (constant 2005 US$) in Suriname?
Give a very brief answer. 1.78e+09. In the year 2001, what is the difference between the Value added (constant 2005 US$) in Bolivia and Value added (constant 2005 US$) in Uruguay?
Give a very brief answer. -1.63e+09. In the year 2001, what is the difference between the Value added (constant 2005 US$) of Latvia and Value added (constant 2005 US$) of Suriname?
Offer a terse response. 2.16e+09. In the year 2001, what is the difference between the Value added (constant 2005 US$) of Latvia and Value added (constant 2005 US$) of Uruguay?
Offer a very short reply. -1.25e+09. In the year 2001, what is the difference between the Value added (constant 2005 US$) of Suriname and Value added (constant 2005 US$) of Uruguay?
Provide a short and direct response. -3.42e+09. In the year 2002, what is the difference between the Value added (constant 2005 US$) in Bolivia and Value added (constant 2005 US$) in Latvia?
Your response must be concise. -6.01e+08. In the year 2002, what is the difference between the Value added (constant 2005 US$) of Bolivia and Value added (constant 2005 US$) of Suriname?
Your answer should be compact. 1.74e+09. In the year 2002, what is the difference between the Value added (constant 2005 US$) in Bolivia and Value added (constant 2005 US$) in Uruguay?
Your answer should be compact. -1.24e+09. In the year 2002, what is the difference between the Value added (constant 2005 US$) of Latvia and Value added (constant 2005 US$) of Suriname?
Provide a succinct answer. 2.34e+09. In the year 2002, what is the difference between the Value added (constant 2005 US$) of Latvia and Value added (constant 2005 US$) of Uruguay?
Offer a terse response. -6.38e+08. In the year 2002, what is the difference between the Value added (constant 2005 US$) in Suriname and Value added (constant 2005 US$) in Uruguay?
Offer a terse response. -2.98e+09. In the year 2003, what is the difference between the Value added (constant 2005 US$) in Bolivia and Value added (constant 2005 US$) in Latvia?
Offer a terse response. -7.69e+08. In the year 2003, what is the difference between the Value added (constant 2005 US$) of Bolivia and Value added (constant 2005 US$) of Suriname?
Keep it short and to the point. 1.73e+09. In the year 2003, what is the difference between the Value added (constant 2005 US$) of Bolivia and Value added (constant 2005 US$) of Uruguay?
Your answer should be compact. -1.27e+09. In the year 2003, what is the difference between the Value added (constant 2005 US$) in Latvia and Value added (constant 2005 US$) in Suriname?
Give a very brief answer. 2.50e+09. In the year 2003, what is the difference between the Value added (constant 2005 US$) in Latvia and Value added (constant 2005 US$) in Uruguay?
Provide a short and direct response. -4.97e+08. In the year 2003, what is the difference between the Value added (constant 2005 US$) in Suriname and Value added (constant 2005 US$) in Uruguay?
Provide a succinct answer. -3.00e+09. In the year 2004, what is the difference between the Value added (constant 2005 US$) of Bolivia and Value added (constant 2005 US$) of Latvia?
Your answer should be very brief. -8.58e+08. In the year 2004, what is the difference between the Value added (constant 2005 US$) in Bolivia and Value added (constant 2005 US$) in Suriname?
Give a very brief answer. 1.81e+09. In the year 2004, what is the difference between the Value added (constant 2005 US$) in Bolivia and Value added (constant 2005 US$) in Uruguay?
Offer a very short reply. -1.25e+09. In the year 2004, what is the difference between the Value added (constant 2005 US$) in Latvia and Value added (constant 2005 US$) in Suriname?
Ensure brevity in your answer.  2.67e+09. In the year 2004, what is the difference between the Value added (constant 2005 US$) in Latvia and Value added (constant 2005 US$) in Uruguay?
Your answer should be very brief. -3.97e+08. In the year 2004, what is the difference between the Value added (constant 2005 US$) in Suriname and Value added (constant 2005 US$) in Uruguay?
Your answer should be compact. -3.06e+09. In the year 2005, what is the difference between the Value added (constant 2005 US$) in Bolivia and Value added (constant 2005 US$) in Latvia?
Your response must be concise. -9.27e+08. In the year 2005, what is the difference between the Value added (constant 2005 US$) of Bolivia and Value added (constant 2005 US$) of Suriname?
Provide a succinct answer. 1.90e+09. In the year 2005, what is the difference between the Value added (constant 2005 US$) of Bolivia and Value added (constant 2005 US$) of Uruguay?
Keep it short and to the point. -1.58e+09. In the year 2005, what is the difference between the Value added (constant 2005 US$) in Latvia and Value added (constant 2005 US$) in Suriname?
Offer a very short reply. 2.83e+09. In the year 2005, what is the difference between the Value added (constant 2005 US$) of Latvia and Value added (constant 2005 US$) of Uruguay?
Your response must be concise. -6.49e+08. In the year 2005, what is the difference between the Value added (constant 2005 US$) in Suriname and Value added (constant 2005 US$) in Uruguay?
Keep it short and to the point. -3.48e+09. In the year 2006, what is the difference between the Value added (constant 2005 US$) of Bolivia and Value added (constant 2005 US$) of Latvia?
Ensure brevity in your answer.  -1.25e+09. In the year 2006, what is the difference between the Value added (constant 2005 US$) of Bolivia and Value added (constant 2005 US$) of Suriname?
Provide a short and direct response. 2.06e+09. In the year 2006, what is the difference between the Value added (constant 2005 US$) in Bolivia and Value added (constant 2005 US$) in Uruguay?
Give a very brief answer. -1.45e+09. In the year 2006, what is the difference between the Value added (constant 2005 US$) in Latvia and Value added (constant 2005 US$) in Suriname?
Offer a terse response. 3.30e+09. In the year 2006, what is the difference between the Value added (constant 2005 US$) in Latvia and Value added (constant 2005 US$) in Uruguay?
Your answer should be compact. -2.07e+08. In the year 2006, what is the difference between the Value added (constant 2005 US$) of Suriname and Value added (constant 2005 US$) of Uruguay?
Ensure brevity in your answer.  -3.51e+09. In the year 2007, what is the difference between the Value added (constant 2005 US$) of Bolivia and Value added (constant 2005 US$) of Latvia?
Give a very brief answer. -1.33e+09. In the year 2007, what is the difference between the Value added (constant 2005 US$) of Bolivia and Value added (constant 2005 US$) of Suriname?
Offer a terse response. 2.22e+09. In the year 2007, what is the difference between the Value added (constant 2005 US$) of Bolivia and Value added (constant 2005 US$) of Uruguay?
Provide a short and direct response. -1.79e+09. In the year 2007, what is the difference between the Value added (constant 2005 US$) of Latvia and Value added (constant 2005 US$) of Suriname?
Ensure brevity in your answer.  3.55e+09. In the year 2007, what is the difference between the Value added (constant 2005 US$) of Latvia and Value added (constant 2005 US$) of Uruguay?
Offer a terse response. -4.63e+08. In the year 2007, what is the difference between the Value added (constant 2005 US$) of Suriname and Value added (constant 2005 US$) of Uruguay?
Make the answer very short. -4.01e+09. What is the ratio of the Value added (constant 2005 US$) in Latvia in 2000 to that in 2001?
Your response must be concise. 0.95. What is the ratio of the Value added (constant 2005 US$) in Suriname in 2000 to that in 2001?
Ensure brevity in your answer.  0.93. What is the ratio of the Value added (constant 2005 US$) in Uruguay in 2000 to that in 2001?
Ensure brevity in your answer.  1.05. What is the ratio of the Value added (constant 2005 US$) of Bolivia in 2000 to that in 2002?
Keep it short and to the point. 0.97. What is the ratio of the Value added (constant 2005 US$) in Latvia in 2000 to that in 2002?
Your answer should be compact. 0.86. What is the ratio of the Value added (constant 2005 US$) in Suriname in 2000 to that in 2002?
Offer a terse response. 0.72. What is the ratio of the Value added (constant 2005 US$) of Uruguay in 2000 to that in 2002?
Offer a very short reply. 1.15. What is the ratio of the Value added (constant 2005 US$) of Bolivia in 2000 to that in 2003?
Your response must be concise. 0.96. What is the ratio of the Value added (constant 2005 US$) in Latvia in 2000 to that in 2003?
Ensure brevity in your answer.  0.8. What is the ratio of the Value added (constant 2005 US$) in Suriname in 2000 to that in 2003?
Your answer should be compact. 0.69. What is the ratio of the Value added (constant 2005 US$) in Uruguay in 2000 to that in 2003?
Provide a short and direct response. 1.14. What is the ratio of the Value added (constant 2005 US$) in Bolivia in 2000 to that in 2004?
Your response must be concise. 0.91. What is the ratio of the Value added (constant 2005 US$) in Latvia in 2000 to that in 2004?
Make the answer very short. 0.75. What is the ratio of the Value added (constant 2005 US$) in Suriname in 2000 to that in 2004?
Offer a terse response. 0.61. What is the ratio of the Value added (constant 2005 US$) in Uruguay in 2000 to that in 2004?
Provide a succinct answer. 1.1. What is the ratio of the Value added (constant 2005 US$) in Bolivia in 2000 to that in 2005?
Make the answer very short. 0.85. What is the ratio of the Value added (constant 2005 US$) of Latvia in 2000 to that in 2005?
Your response must be concise. 0.7. What is the ratio of the Value added (constant 2005 US$) in Suriname in 2000 to that in 2005?
Keep it short and to the point. 0.55. What is the ratio of the Value added (constant 2005 US$) of Uruguay in 2000 to that in 2005?
Give a very brief answer. 0.97. What is the ratio of the Value added (constant 2005 US$) in Bolivia in 2000 to that in 2006?
Offer a very short reply. 0.8. What is the ratio of the Value added (constant 2005 US$) in Latvia in 2000 to that in 2006?
Provide a short and direct response. 0.61. What is the ratio of the Value added (constant 2005 US$) in Suriname in 2000 to that in 2006?
Your answer should be compact. 0.53. What is the ratio of the Value added (constant 2005 US$) of Uruguay in 2000 to that in 2006?
Ensure brevity in your answer.  0.96. What is the ratio of the Value added (constant 2005 US$) of Bolivia in 2000 to that in 2007?
Offer a terse response. 0.74. What is the ratio of the Value added (constant 2005 US$) in Latvia in 2000 to that in 2007?
Offer a terse response. 0.57. What is the ratio of the Value added (constant 2005 US$) in Suriname in 2000 to that in 2007?
Your answer should be very brief. 0.51. What is the ratio of the Value added (constant 2005 US$) in Uruguay in 2000 to that in 2007?
Make the answer very short. 0.85. What is the ratio of the Value added (constant 2005 US$) of Bolivia in 2001 to that in 2002?
Give a very brief answer. 0.97. What is the ratio of the Value added (constant 2005 US$) of Latvia in 2001 to that in 2002?
Keep it short and to the point. 0.9. What is the ratio of the Value added (constant 2005 US$) in Suriname in 2001 to that in 2002?
Provide a short and direct response. 0.78. What is the ratio of the Value added (constant 2005 US$) of Uruguay in 2001 to that in 2002?
Your answer should be very brief. 1.1. What is the ratio of the Value added (constant 2005 US$) of Bolivia in 2001 to that in 2003?
Your response must be concise. 0.97. What is the ratio of the Value added (constant 2005 US$) of Latvia in 2001 to that in 2003?
Give a very brief answer. 0.84. What is the ratio of the Value added (constant 2005 US$) of Suriname in 2001 to that in 2003?
Offer a very short reply. 0.74. What is the ratio of the Value added (constant 2005 US$) of Uruguay in 2001 to that in 2003?
Make the answer very short. 1.08. What is the ratio of the Value added (constant 2005 US$) of Bolivia in 2001 to that in 2004?
Make the answer very short. 0.91. What is the ratio of the Value added (constant 2005 US$) in Latvia in 2001 to that in 2004?
Offer a terse response. 0.78. What is the ratio of the Value added (constant 2005 US$) of Suriname in 2001 to that in 2004?
Provide a short and direct response. 0.65. What is the ratio of the Value added (constant 2005 US$) of Uruguay in 2001 to that in 2004?
Give a very brief answer. 1.04. What is the ratio of the Value added (constant 2005 US$) in Bolivia in 2001 to that in 2005?
Make the answer very short. 0.85. What is the ratio of the Value added (constant 2005 US$) of Latvia in 2001 to that in 2005?
Provide a succinct answer. 0.73. What is the ratio of the Value added (constant 2005 US$) in Suriname in 2001 to that in 2005?
Offer a very short reply. 0.59. What is the ratio of the Value added (constant 2005 US$) in Uruguay in 2001 to that in 2005?
Your response must be concise. 0.92. What is the ratio of the Value added (constant 2005 US$) in Bolivia in 2001 to that in 2006?
Your answer should be compact. 0.8. What is the ratio of the Value added (constant 2005 US$) in Latvia in 2001 to that in 2006?
Your answer should be compact. 0.64. What is the ratio of the Value added (constant 2005 US$) of Suriname in 2001 to that in 2006?
Give a very brief answer. 0.57. What is the ratio of the Value added (constant 2005 US$) of Uruguay in 2001 to that in 2006?
Provide a short and direct response. 0.91. What is the ratio of the Value added (constant 2005 US$) of Bolivia in 2001 to that in 2007?
Make the answer very short. 0.75. What is the ratio of the Value added (constant 2005 US$) of Latvia in 2001 to that in 2007?
Offer a very short reply. 0.6. What is the ratio of the Value added (constant 2005 US$) of Suriname in 2001 to that in 2007?
Your response must be concise. 0.55. What is the ratio of the Value added (constant 2005 US$) in Uruguay in 2001 to that in 2007?
Provide a succinct answer. 0.81. What is the ratio of the Value added (constant 2005 US$) in Latvia in 2002 to that in 2003?
Offer a terse response. 0.94. What is the ratio of the Value added (constant 2005 US$) in Suriname in 2002 to that in 2003?
Offer a very short reply. 0.95. What is the ratio of the Value added (constant 2005 US$) in Uruguay in 2002 to that in 2003?
Your response must be concise. 0.99. What is the ratio of the Value added (constant 2005 US$) of Bolivia in 2002 to that in 2004?
Your answer should be very brief. 0.93. What is the ratio of the Value added (constant 2005 US$) of Latvia in 2002 to that in 2004?
Make the answer very short. 0.87. What is the ratio of the Value added (constant 2005 US$) in Suriname in 2002 to that in 2004?
Ensure brevity in your answer.  0.84. What is the ratio of the Value added (constant 2005 US$) in Uruguay in 2002 to that in 2004?
Provide a short and direct response. 0.95. What is the ratio of the Value added (constant 2005 US$) of Bolivia in 2002 to that in 2005?
Offer a very short reply. 0.88. What is the ratio of the Value added (constant 2005 US$) of Latvia in 2002 to that in 2005?
Give a very brief answer. 0.81. What is the ratio of the Value added (constant 2005 US$) of Suriname in 2002 to that in 2005?
Give a very brief answer. 0.75. What is the ratio of the Value added (constant 2005 US$) in Uruguay in 2002 to that in 2005?
Keep it short and to the point. 0.84. What is the ratio of the Value added (constant 2005 US$) in Bolivia in 2002 to that in 2006?
Keep it short and to the point. 0.82. What is the ratio of the Value added (constant 2005 US$) of Latvia in 2002 to that in 2006?
Offer a terse response. 0.71. What is the ratio of the Value added (constant 2005 US$) of Suriname in 2002 to that in 2006?
Your answer should be compact. 0.73. What is the ratio of the Value added (constant 2005 US$) of Uruguay in 2002 to that in 2006?
Keep it short and to the point. 0.83. What is the ratio of the Value added (constant 2005 US$) in Bolivia in 2002 to that in 2007?
Give a very brief answer. 0.77. What is the ratio of the Value added (constant 2005 US$) of Latvia in 2002 to that in 2007?
Your response must be concise. 0.67. What is the ratio of the Value added (constant 2005 US$) of Suriname in 2002 to that in 2007?
Your answer should be compact. 0.7. What is the ratio of the Value added (constant 2005 US$) in Uruguay in 2002 to that in 2007?
Provide a succinct answer. 0.74. What is the ratio of the Value added (constant 2005 US$) of Bolivia in 2003 to that in 2004?
Provide a succinct answer. 0.94. What is the ratio of the Value added (constant 2005 US$) of Latvia in 2003 to that in 2004?
Provide a short and direct response. 0.93. What is the ratio of the Value added (constant 2005 US$) of Suriname in 2003 to that in 2004?
Provide a succinct answer. 0.88. What is the ratio of the Value added (constant 2005 US$) of Uruguay in 2003 to that in 2004?
Your response must be concise. 0.96. What is the ratio of the Value added (constant 2005 US$) of Bolivia in 2003 to that in 2005?
Your answer should be very brief. 0.88. What is the ratio of the Value added (constant 2005 US$) in Latvia in 2003 to that in 2005?
Keep it short and to the point. 0.87. What is the ratio of the Value added (constant 2005 US$) of Suriname in 2003 to that in 2005?
Offer a terse response. 0.8. What is the ratio of the Value added (constant 2005 US$) of Uruguay in 2003 to that in 2005?
Give a very brief answer. 0.85. What is the ratio of the Value added (constant 2005 US$) in Bolivia in 2003 to that in 2006?
Your response must be concise. 0.83. What is the ratio of the Value added (constant 2005 US$) of Latvia in 2003 to that in 2006?
Offer a terse response. 0.76. What is the ratio of the Value added (constant 2005 US$) of Suriname in 2003 to that in 2006?
Keep it short and to the point. 0.77. What is the ratio of the Value added (constant 2005 US$) in Uruguay in 2003 to that in 2006?
Offer a very short reply. 0.84. What is the ratio of the Value added (constant 2005 US$) of Bolivia in 2003 to that in 2007?
Keep it short and to the point. 0.77. What is the ratio of the Value added (constant 2005 US$) of Latvia in 2003 to that in 2007?
Ensure brevity in your answer.  0.71. What is the ratio of the Value added (constant 2005 US$) of Suriname in 2003 to that in 2007?
Your answer should be compact. 0.74. What is the ratio of the Value added (constant 2005 US$) of Uruguay in 2003 to that in 2007?
Give a very brief answer. 0.75. What is the ratio of the Value added (constant 2005 US$) of Bolivia in 2004 to that in 2005?
Your answer should be very brief. 0.94. What is the ratio of the Value added (constant 2005 US$) of Latvia in 2004 to that in 2005?
Provide a succinct answer. 0.94. What is the ratio of the Value added (constant 2005 US$) of Suriname in 2004 to that in 2005?
Provide a short and direct response. 0.9. What is the ratio of the Value added (constant 2005 US$) in Uruguay in 2004 to that in 2005?
Provide a short and direct response. 0.88. What is the ratio of the Value added (constant 2005 US$) in Bolivia in 2004 to that in 2006?
Your answer should be compact. 0.88. What is the ratio of the Value added (constant 2005 US$) of Latvia in 2004 to that in 2006?
Make the answer very short. 0.82. What is the ratio of the Value added (constant 2005 US$) of Suriname in 2004 to that in 2006?
Ensure brevity in your answer.  0.88. What is the ratio of the Value added (constant 2005 US$) in Uruguay in 2004 to that in 2006?
Ensure brevity in your answer.  0.87. What is the ratio of the Value added (constant 2005 US$) of Bolivia in 2004 to that in 2007?
Your answer should be compact. 0.82. What is the ratio of the Value added (constant 2005 US$) of Latvia in 2004 to that in 2007?
Ensure brevity in your answer.  0.77. What is the ratio of the Value added (constant 2005 US$) of Suriname in 2004 to that in 2007?
Your response must be concise. 0.84. What is the ratio of the Value added (constant 2005 US$) in Uruguay in 2004 to that in 2007?
Provide a short and direct response. 0.77. What is the ratio of the Value added (constant 2005 US$) of Bolivia in 2005 to that in 2006?
Your answer should be compact. 0.94. What is the ratio of the Value added (constant 2005 US$) of Latvia in 2005 to that in 2006?
Make the answer very short. 0.87. What is the ratio of the Value added (constant 2005 US$) in Suriname in 2005 to that in 2006?
Keep it short and to the point. 0.97. What is the ratio of the Value added (constant 2005 US$) of Uruguay in 2005 to that in 2006?
Keep it short and to the point. 0.99. What is the ratio of the Value added (constant 2005 US$) in Bolivia in 2005 to that in 2007?
Keep it short and to the point. 0.87. What is the ratio of the Value added (constant 2005 US$) of Latvia in 2005 to that in 2007?
Your answer should be very brief. 0.82. What is the ratio of the Value added (constant 2005 US$) of Suriname in 2005 to that in 2007?
Give a very brief answer. 0.93. What is the ratio of the Value added (constant 2005 US$) in Uruguay in 2005 to that in 2007?
Keep it short and to the point. 0.88. What is the ratio of the Value added (constant 2005 US$) in Bolivia in 2006 to that in 2007?
Make the answer very short. 0.93. What is the ratio of the Value added (constant 2005 US$) of Latvia in 2006 to that in 2007?
Offer a very short reply. 0.94. What is the ratio of the Value added (constant 2005 US$) of Suriname in 2006 to that in 2007?
Offer a very short reply. 0.96. What is the ratio of the Value added (constant 2005 US$) in Uruguay in 2006 to that in 2007?
Offer a terse response. 0.89. What is the difference between the highest and the second highest Value added (constant 2005 US$) in Bolivia?
Provide a succinct answer. 1.88e+08. What is the difference between the highest and the second highest Value added (constant 2005 US$) in Latvia?
Ensure brevity in your answer.  2.67e+08. What is the difference between the highest and the second highest Value added (constant 2005 US$) of Suriname?
Your answer should be compact. 2.49e+07. What is the difference between the highest and the second highest Value added (constant 2005 US$) of Uruguay?
Make the answer very short. 5.24e+08. What is the difference between the highest and the lowest Value added (constant 2005 US$) of Bolivia?
Ensure brevity in your answer.  7.35e+08. What is the difference between the highest and the lowest Value added (constant 2005 US$) in Latvia?
Offer a very short reply. 1.79e+09. What is the difference between the highest and the lowest Value added (constant 2005 US$) of Suriname?
Your answer should be compact. 3.18e+08. What is the difference between the highest and the lowest Value added (constant 2005 US$) of Uruguay?
Your answer should be very brief. 1.22e+09. 